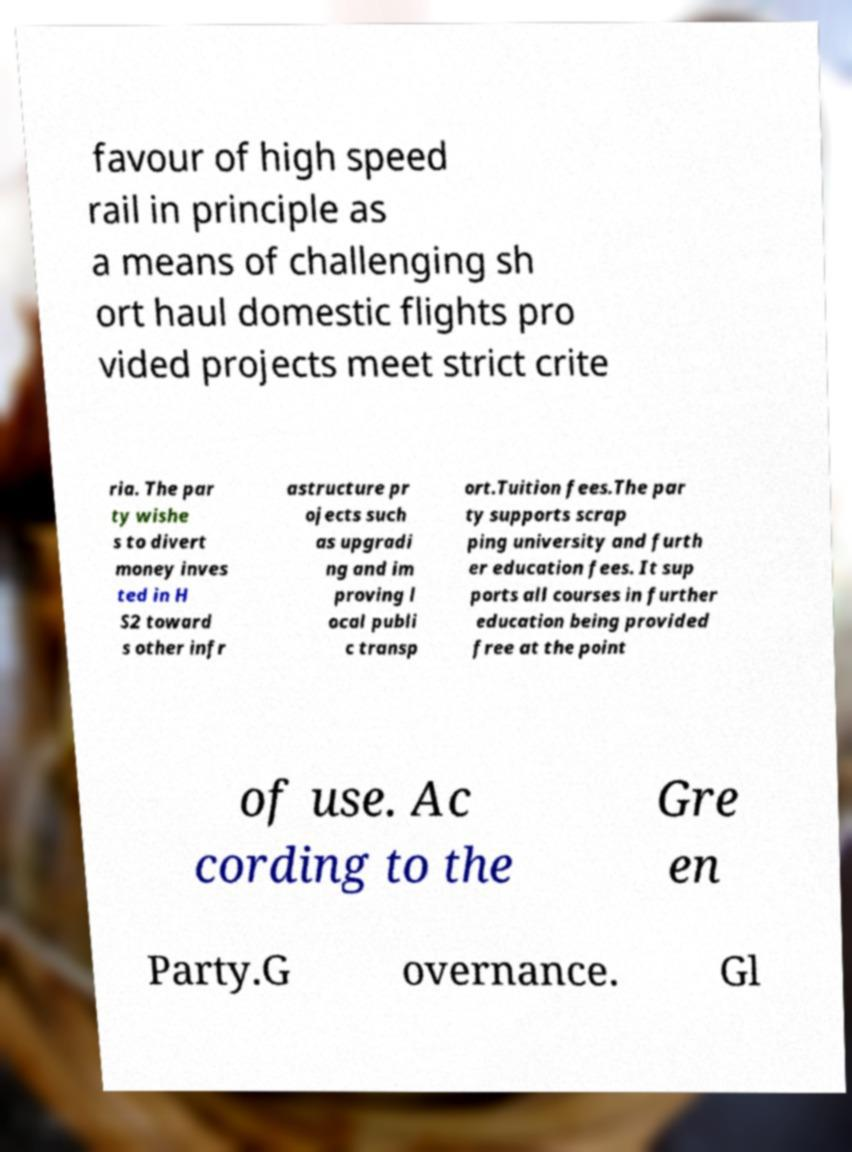What messages or text are displayed in this image? I need them in a readable, typed format. favour of high speed rail in principle as a means of challenging sh ort haul domestic flights pro vided projects meet strict crite ria. The par ty wishe s to divert money inves ted in H S2 toward s other infr astructure pr ojects such as upgradi ng and im proving l ocal publi c transp ort.Tuition fees.The par ty supports scrap ping university and furth er education fees. It sup ports all courses in further education being provided free at the point of use. Ac cording to the Gre en Party.G overnance. Gl 